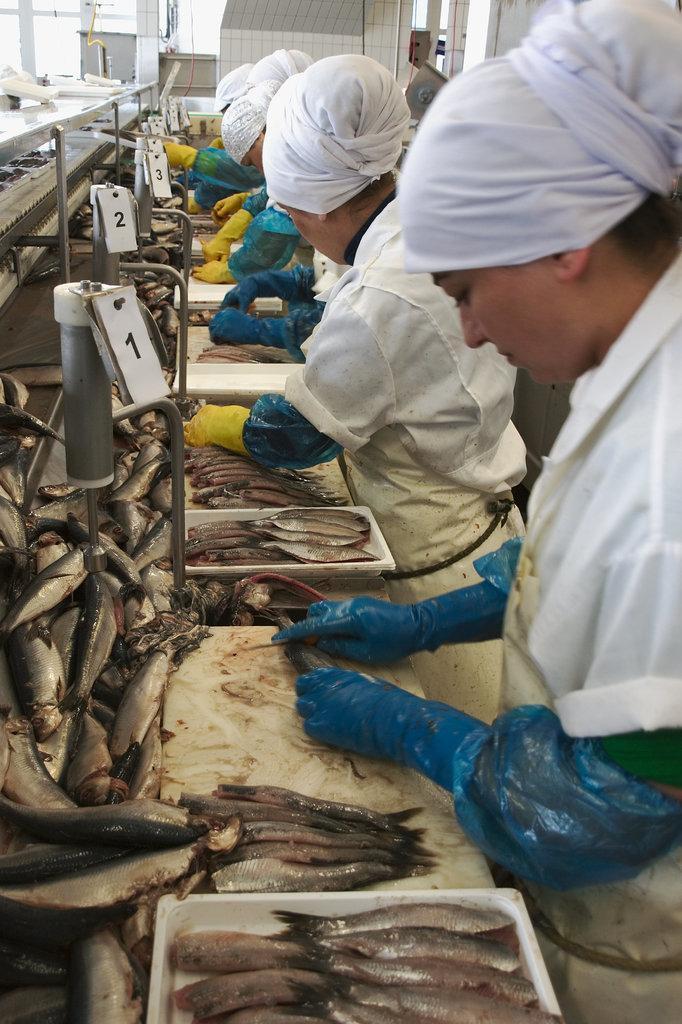In one or two sentences, can you explain what this image depicts? Here I can see many fishes, trays and some other objects placed on a table. On the right side few people are wearing aprons, gloves to their hands and standing. It seems like they are cutting the fishes. In the background there are few tables, pillars and a wall. 